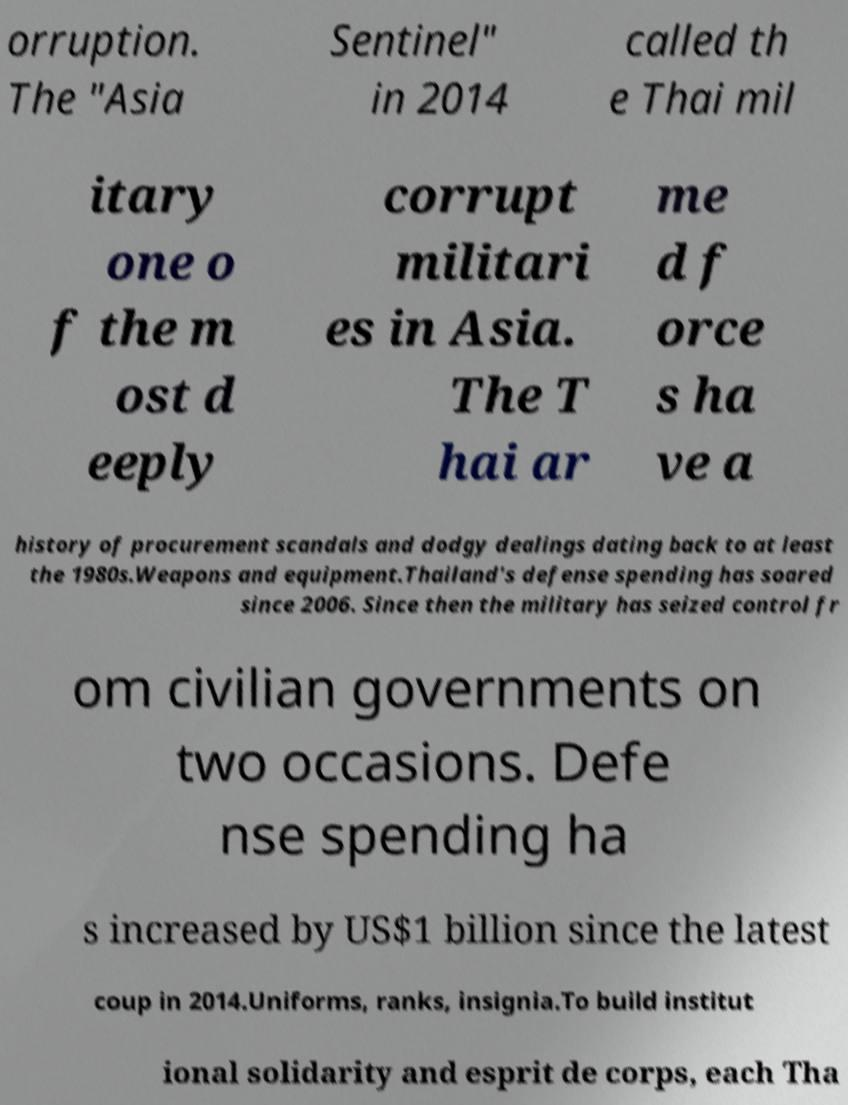I need the written content from this picture converted into text. Can you do that? orruption. The "Asia Sentinel" in 2014 called th e Thai mil itary one o f the m ost d eeply corrupt militari es in Asia. The T hai ar me d f orce s ha ve a history of procurement scandals and dodgy dealings dating back to at least the 1980s.Weapons and equipment.Thailand's defense spending has soared since 2006. Since then the military has seized control fr om civilian governments on two occasions. Defe nse spending ha s increased by US$1 billion since the latest coup in 2014.Uniforms, ranks, insignia.To build institut ional solidarity and esprit de corps, each Tha 